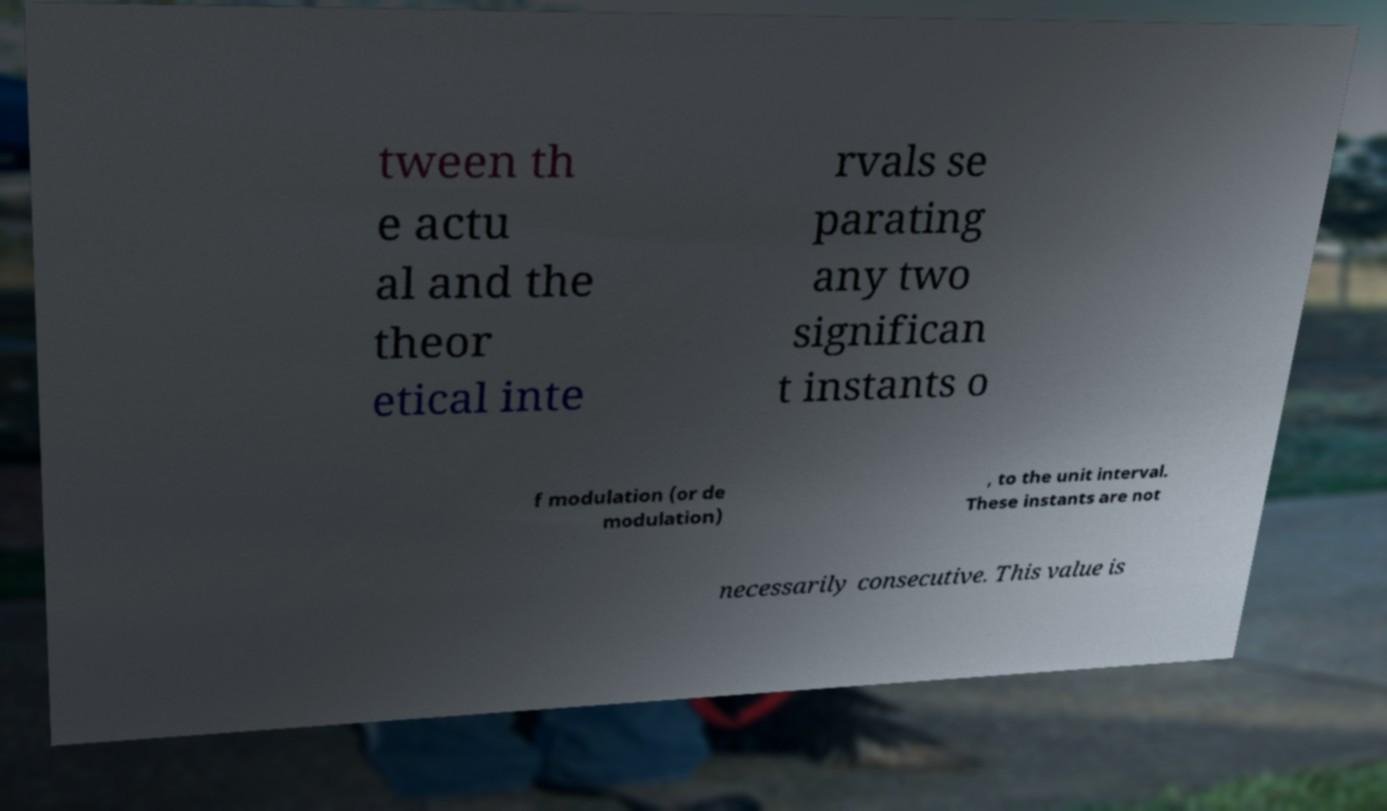Could you assist in decoding the text presented in this image and type it out clearly? tween th e actu al and the theor etical inte rvals se parating any two significan t instants o f modulation (or de modulation) , to the unit interval. These instants are not necessarily consecutive. This value is 